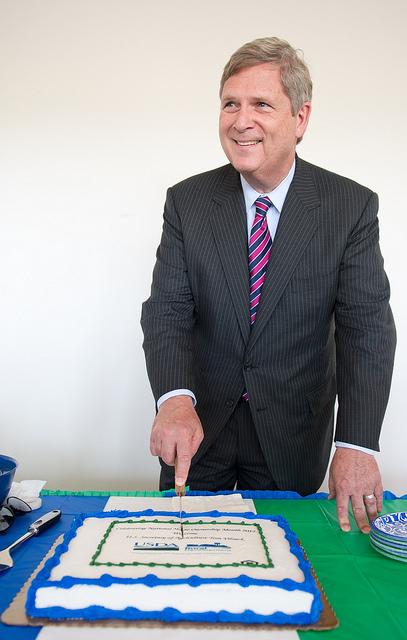What US President does this person resemble?
Quick response, please. George bush. Is he cutting a cake?
Answer briefly. Yes. Is he smiling?
Give a very brief answer. Yes. 